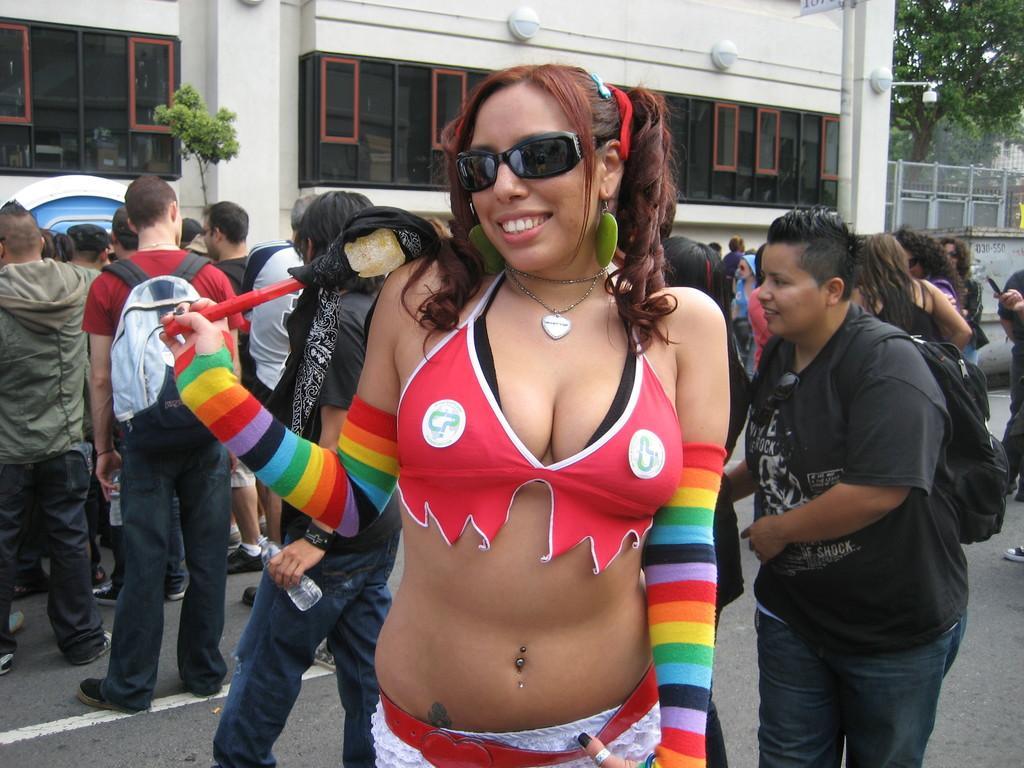Please provide a concise description of this image. On the left side of the image we can see some person are standing and a tree is there. In the middle of the image we can see lady and she is holding something in her hands. On the right side of the image we can see some persons are standing and some trees are there. 